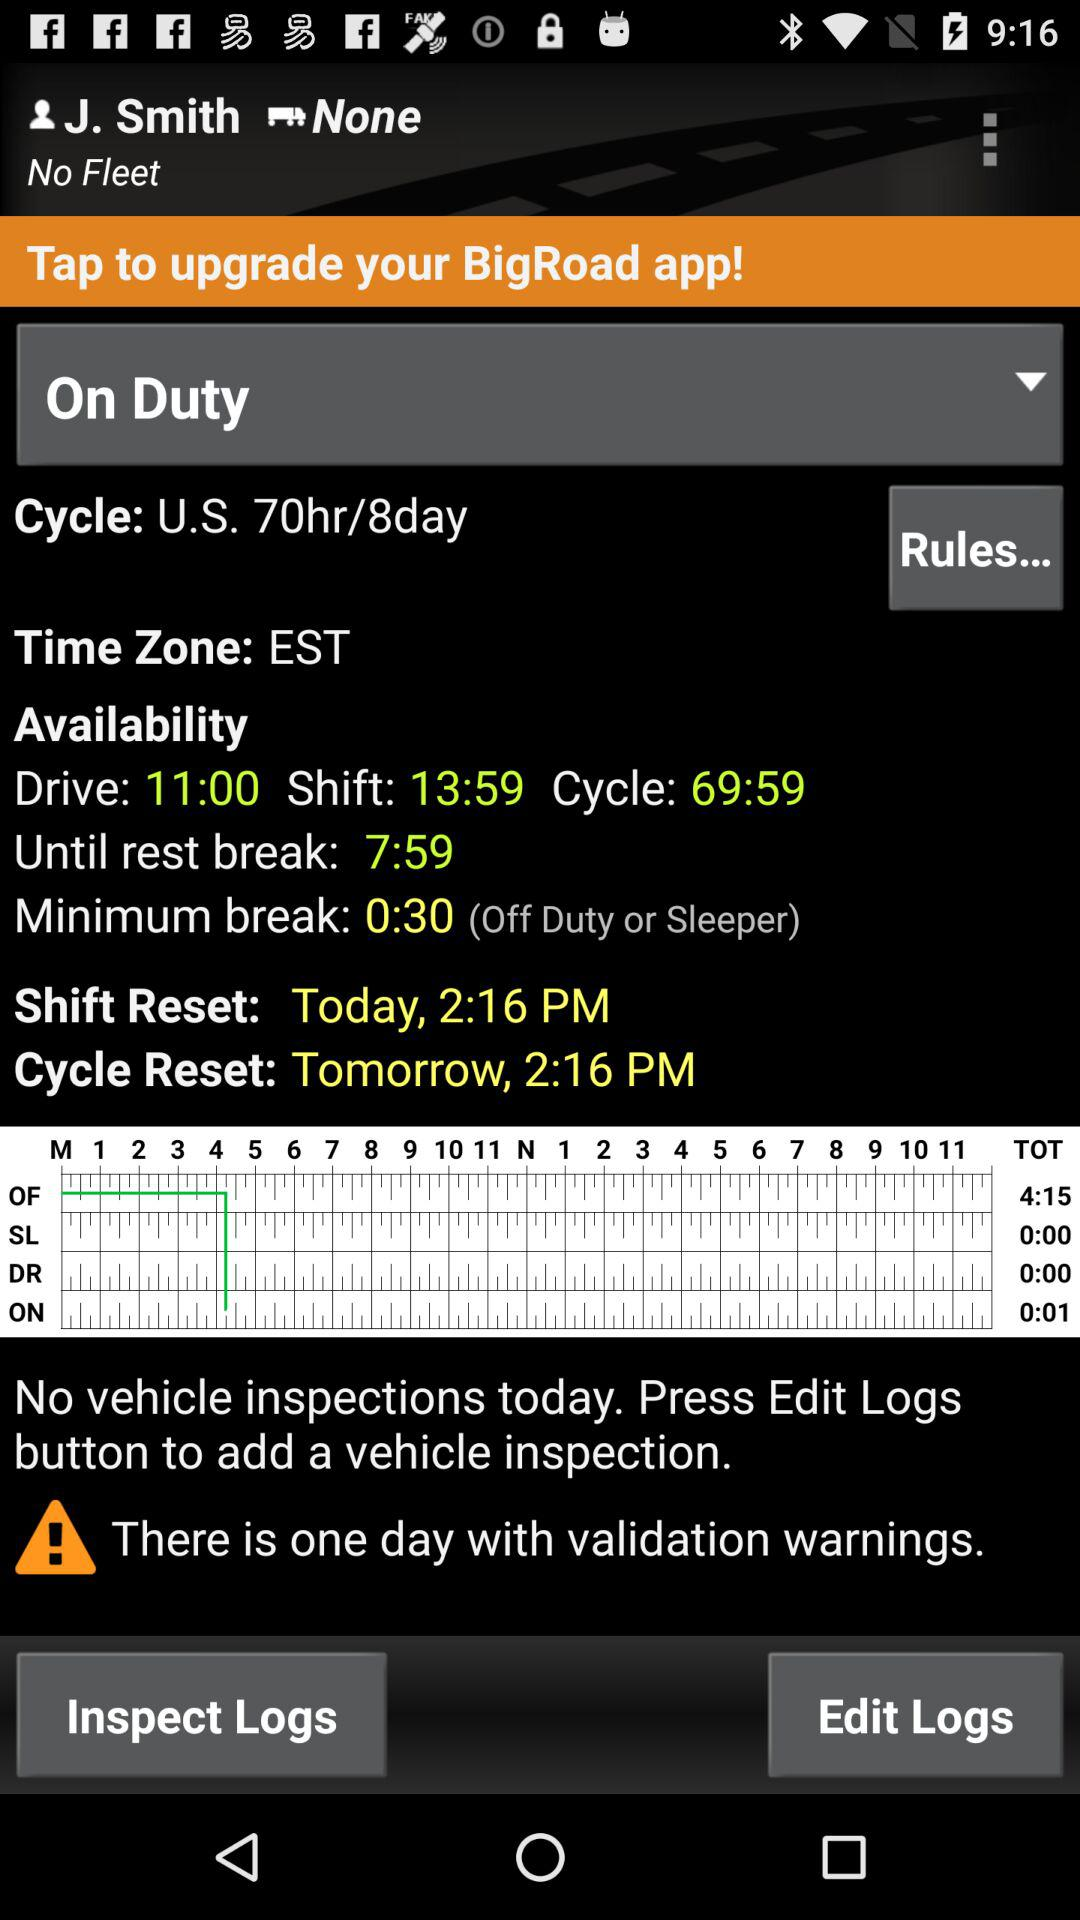What is the time zone? The time zone is Eastern Standard Time. 